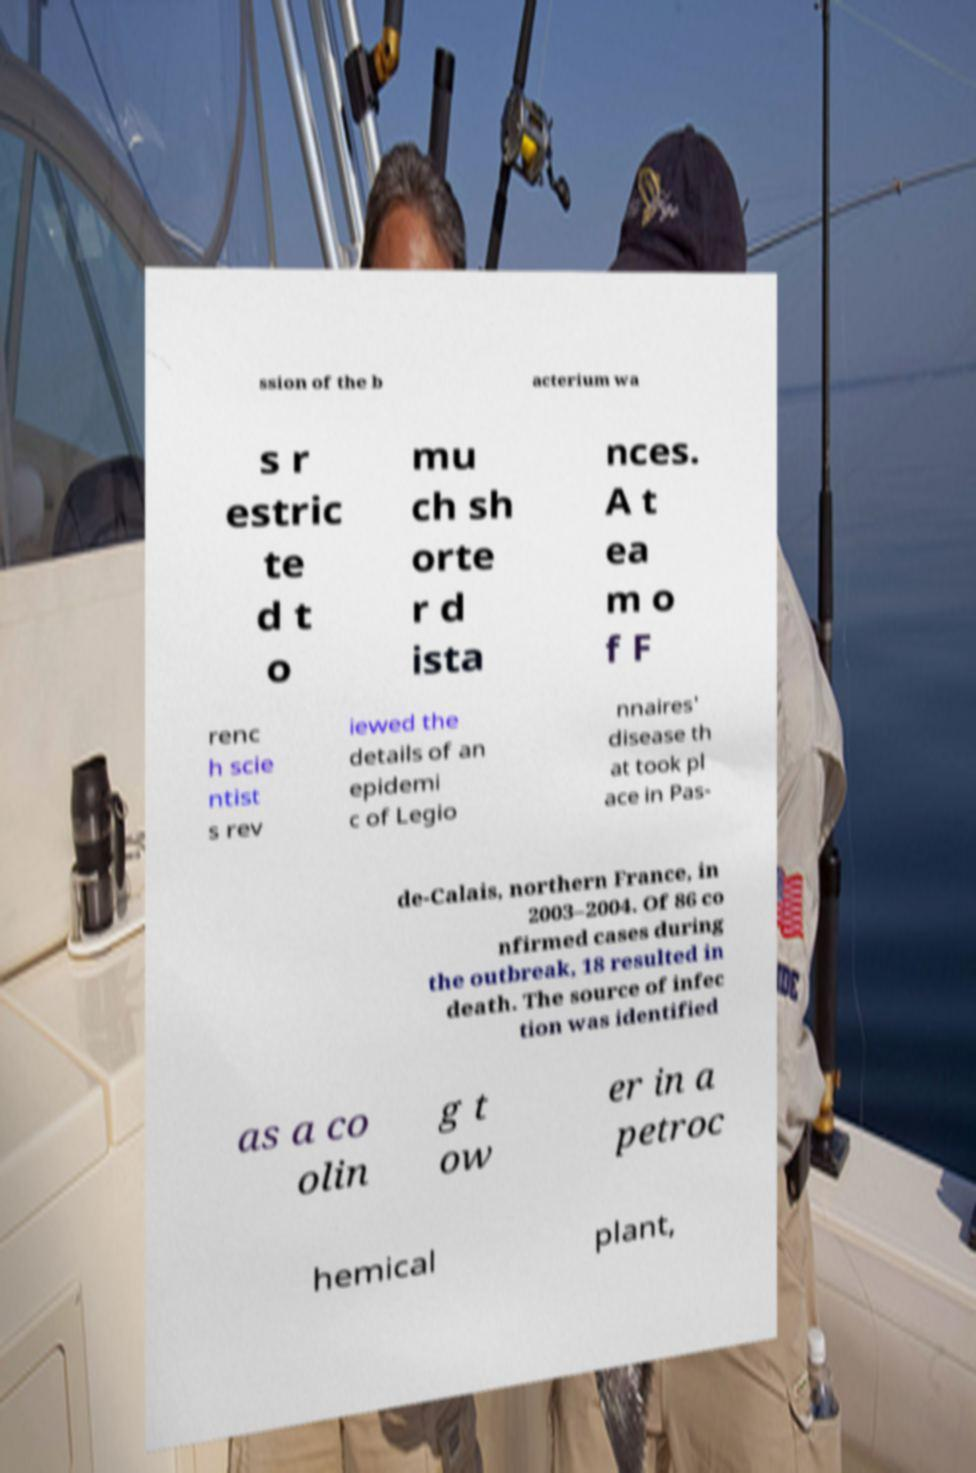I need the written content from this picture converted into text. Can you do that? ssion of the b acterium wa s r estric te d t o mu ch sh orte r d ista nces. A t ea m o f F renc h scie ntist s rev iewed the details of an epidemi c of Legio nnaires' disease th at took pl ace in Pas- de-Calais, northern France, in 2003–2004. Of 86 co nfirmed cases during the outbreak, 18 resulted in death. The source of infec tion was identified as a co olin g t ow er in a petroc hemical plant, 